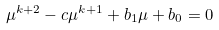Convert formula to latex. <formula><loc_0><loc_0><loc_500><loc_500>\mu ^ { k + 2 } - c \mu ^ { k + 1 } + b _ { 1 } \mu + b _ { 0 } = 0</formula> 